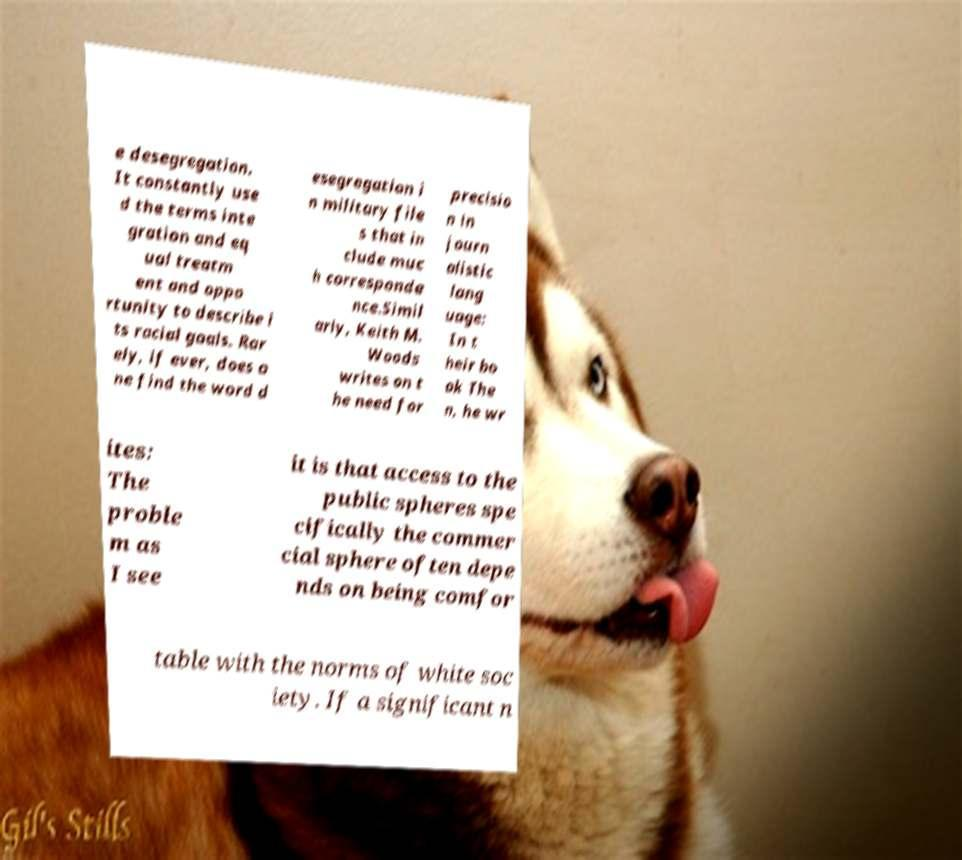Could you assist in decoding the text presented in this image and type it out clearly? e desegregation. It constantly use d the terms inte gration and eq ual treatm ent and oppo rtunity to describe i ts racial goals. Rar ely, if ever, does o ne find the word d esegregation i n military file s that in clude muc h corresponde nce.Simil arly, Keith M. Woods writes on t he need for precisio n in journ alistic lang uage: In t heir bo ok The n, he wr ites: The proble m as I see it is that access to the public spheres spe cifically the commer cial sphere often depe nds on being comfor table with the norms of white soc iety. If a significant n 